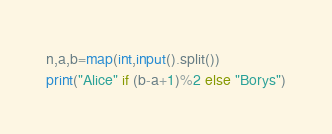Convert code to text. <code><loc_0><loc_0><loc_500><loc_500><_Python_>n,a,b=map(int,input().split())
print("Alice" if (b-a+1)%2 else "Borys")</code> 